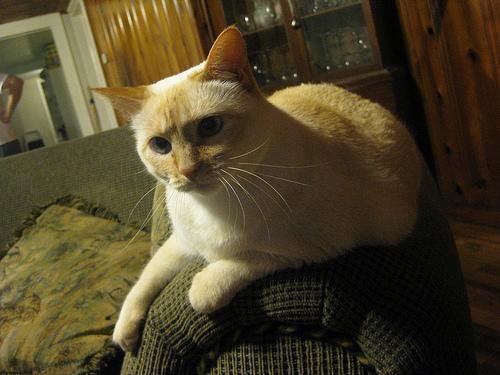How many cats are there?
Give a very brief answer. 1. How many colors is the cat's fur?
Give a very brief answer. 2. 